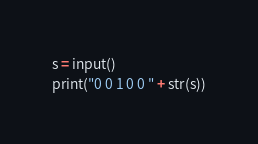Convert code to text. <code><loc_0><loc_0><loc_500><loc_500><_Python_>s = input()
print("0 0 1 0 0 " + str(s))</code> 